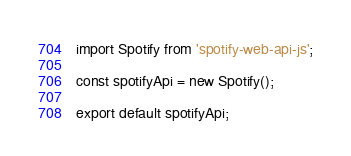Convert code to text. <code><loc_0><loc_0><loc_500><loc_500><_JavaScript_>import Spotify from 'spotify-web-api-js';

const spotifyApi = new Spotify();

export default spotifyApi;
</code> 